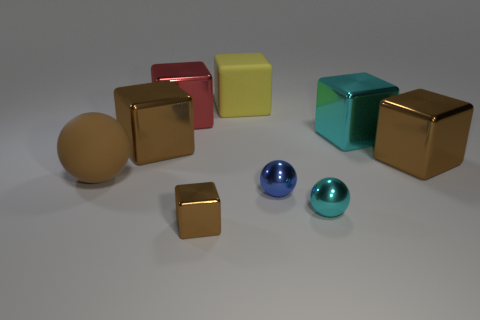What number of large red objects are made of the same material as the tiny brown cube?
Make the answer very short. 1. How many objects are large metal cubes or spheres in front of the brown matte thing?
Offer a terse response. 6. Is the large brown cube to the right of the tiny cyan object made of the same material as the large red thing?
Make the answer very short. Yes. There is a sphere that is the same size as the yellow block; what is its color?
Make the answer very short. Brown. Is there a big brown rubber object that has the same shape as the big cyan metallic thing?
Offer a very short reply. No. The large matte thing that is behind the brown cube that is behind the big brown metallic object that is on the right side of the big yellow thing is what color?
Provide a succinct answer. Yellow. What number of rubber objects are either tiny balls or balls?
Offer a very short reply. 1. Are there more cyan things that are behind the tiny blue metallic sphere than small shiny balls that are to the right of the small cyan metallic sphere?
Provide a succinct answer. Yes. What number of other things are there of the same size as the red block?
Provide a short and direct response. 5. There is a brown thing that is to the left of the large brown shiny cube on the left side of the yellow cube; how big is it?
Ensure brevity in your answer.  Large. 